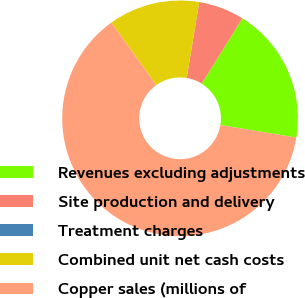<chart> <loc_0><loc_0><loc_500><loc_500><pie_chart><fcel>Revenues excluding adjustments<fcel>Site production and delivery<fcel>Treatment charges<fcel>Combined unit net cash costs<fcel>Copper sales (millions of<nl><fcel>18.75%<fcel>6.26%<fcel>0.01%<fcel>12.5%<fcel>62.48%<nl></chart> 